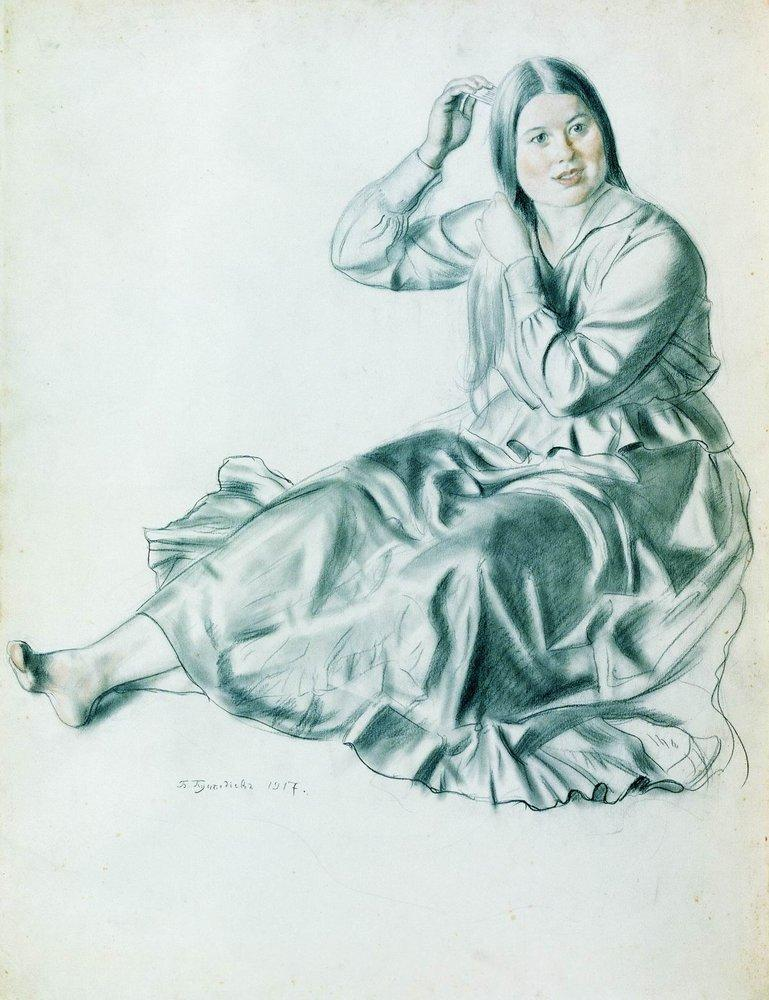Can you imagine a story behind this sketch? Certainly! Imagine this woman as a young poet living in the early 20th century. Each morning, she takes a moment to sit in front of her window, feeling the gentle morning breeze as she combs her hair, a ritual that calms her mind before she begins to write. Her serene expression belies a mind full of creativity and deep thoughts. The artist, possibly a close friend or admirer, decided to capture her in one of these tranquil moments, hoping to encapsulate the peaceful yet intense world of contemplation and creation in which she dwells. 